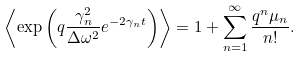<formula> <loc_0><loc_0><loc_500><loc_500>\left \langle \exp \left ( q \frac { \gamma _ { n } ^ { 2 } } { \Delta \omega ^ { 2 } } e ^ { - 2 \gamma _ { n } t } \right ) \right \rangle = 1 + \sum _ { n = 1 } ^ { \infty } \frac { q ^ { n } \mu _ { n } } { n ! } .</formula> 